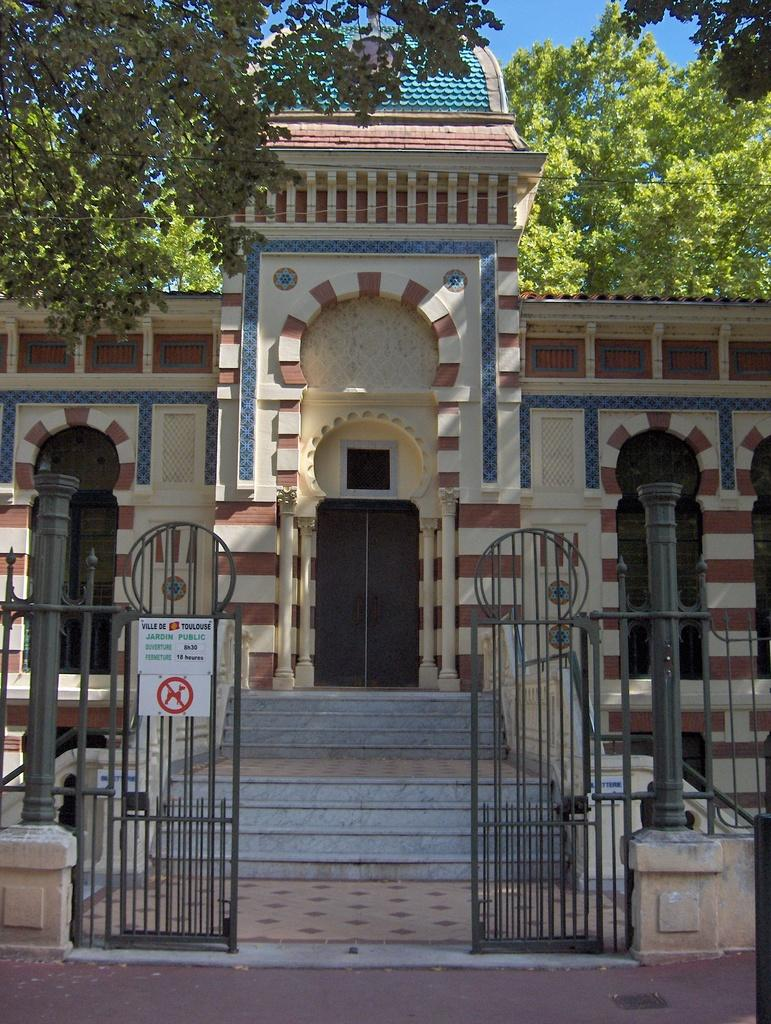What type of structure is visible in the image? There is a building in the image. What are the entrances to the building like? There are doors in the image. What type of vegetation is present in the image? There are trees in the image. What is the main feature of the entrance to the building? There is a gate in the image, and boards are attached to it. What is the color of the sky in the image? The sky is blue in color. What type of marble is used to decorate the vegetable garden in the image? There is no marble or vegetable garden present in the image. What type of copper utensils can be seen in the image? There are no copper utensils visible in the image. 